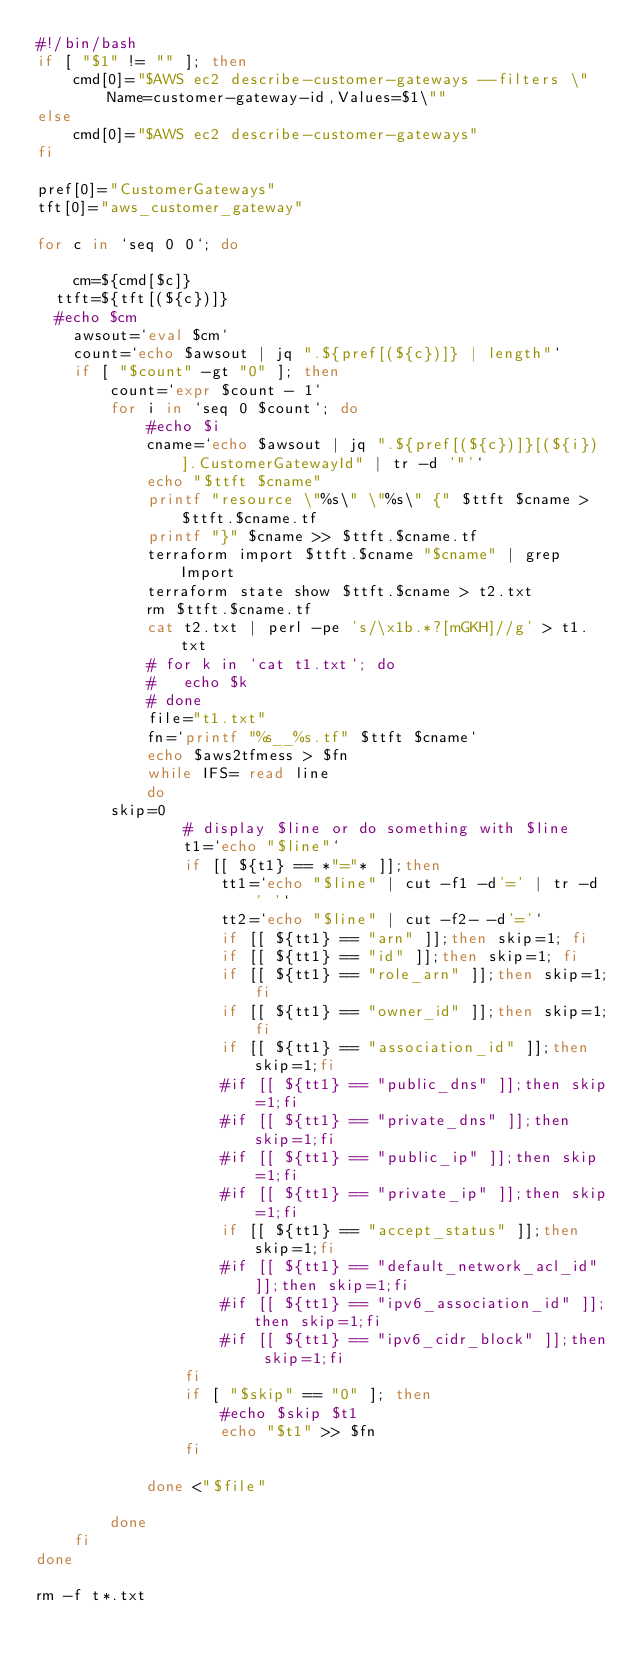Convert code to text. <code><loc_0><loc_0><loc_500><loc_500><_Bash_>#!/bin/bash
if [ "$1" != "" ]; then
    cmd[0]="$AWS ec2 describe-customer-gateways --filters \"Name=customer-gateway-id,Values=$1\"" 
else
    cmd[0]="$AWS ec2 describe-customer-gateways"
fi

pref[0]="CustomerGateways"
tft[0]="aws_customer_gateway"

for c in `seq 0 0`; do
 
    cm=${cmd[$c]}
	ttft=${tft[(${c})]}
	#echo $cm
    awsout=`eval $cm`
    count=`echo $awsout | jq ".${pref[(${c})]} | length"`
    if [ "$count" -gt "0" ]; then
        count=`expr $count - 1`
        for i in `seq 0 $count`; do
            #echo $i
            cname=`echo $awsout | jq ".${pref[(${c})]}[(${i})].CustomerGatewayId" | tr -d '"'`
            echo "$ttft $cname"
            printf "resource \"%s\" \"%s\" {" $ttft $cname > $ttft.$cname.tf
            printf "}" $cname >> $ttft.$cname.tf
            terraform import $ttft.$cname "$cname" | grep Import
            terraform state show $ttft.$cname > t2.txt
            rm $ttft.$cname.tf
            cat t2.txt | perl -pe 's/\x1b.*?[mGKH]//g' > t1.txt
            #	for k in `cat t1.txt`; do
            #		echo $k
            #	done
            file="t1.txt"
            fn=`printf "%s__%s.tf" $ttft $cname`
            echo $aws2tfmess > $fn
            while IFS= read line
            do
				skip=0
                # display $line or do something with $line
                t1=`echo "$line"` 
                if [[ ${t1} == *"="* ]];then
                    tt1=`echo "$line" | cut -f1 -d'=' | tr -d ' '` 
                    tt2=`echo "$line" | cut -f2- -d'='`
                    if [[ ${tt1} == "arn" ]];then skip=1; fi                
                    if [[ ${tt1} == "id" ]];then skip=1; fi          
                    if [[ ${tt1} == "role_arn" ]];then skip=1;fi
                    if [[ ${tt1} == "owner_id" ]];then skip=1;fi
                    if [[ ${tt1} == "association_id" ]];then skip=1;fi
                    #if [[ ${tt1} == "public_dns" ]];then skip=1;fi
                    #if [[ ${tt1} == "private_dns" ]];then skip=1;fi
                    #if [[ ${tt1} == "public_ip" ]];then skip=1;fi
                    #if [[ ${tt1} == "private_ip" ]];then skip=1;fi
                    if [[ ${tt1} == "accept_status" ]];then skip=1;fi
                    #if [[ ${tt1} == "default_network_acl_id" ]];then skip=1;fi
                    #if [[ ${tt1} == "ipv6_association_id" ]];then skip=1;fi
                    #if [[ ${tt1} == "ipv6_cidr_block" ]];then skip=1;fi
                fi
                if [ "$skip" == "0" ]; then
                    #echo $skip $t1
                    echo "$t1" >> $fn
                fi
                
            done <"$file"
            
        done
    fi
done

rm -f t*.txt

</code> 